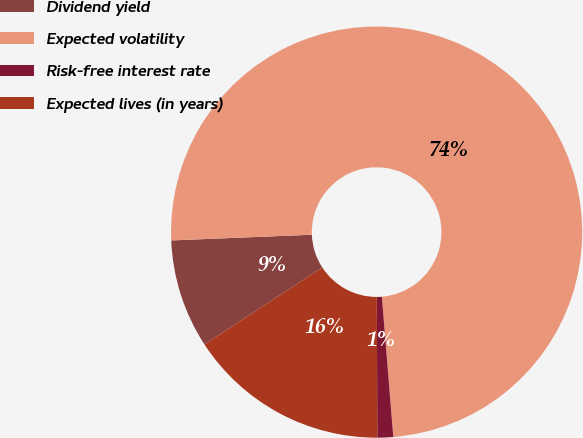Convert chart. <chart><loc_0><loc_0><loc_500><loc_500><pie_chart><fcel>Dividend yield<fcel>Expected volatility<fcel>Risk-free interest rate<fcel>Expected lives (in years)<nl><fcel>8.55%<fcel>74.36%<fcel>1.24%<fcel>15.86%<nl></chart> 